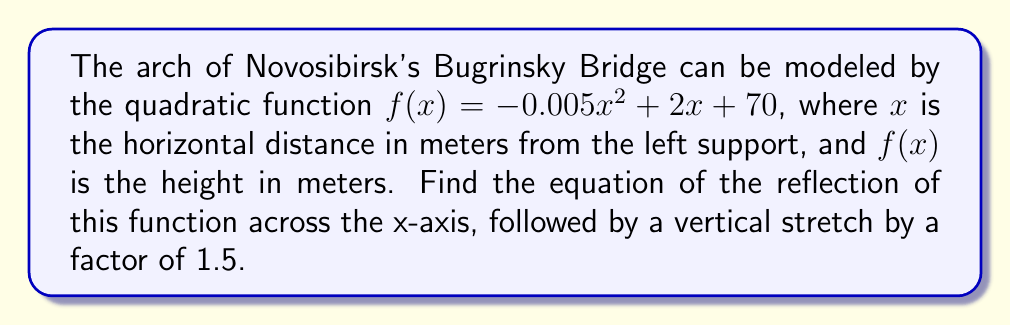Can you solve this math problem? To solve this problem, we'll follow these steps:

1) First, let's reflect the function across the x-axis. This is done by negating the entire function:

   $g(x) = -f(x) = -(-0.005x^2 + 2x + 70)$
   $g(x) = 0.005x^2 - 2x - 70$

2) Now, we need to apply a vertical stretch by a factor of 1.5. This is done by multiplying the entire function by 1.5:

   $h(x) = 1.5g(x) = 1.5(0.005x^2 - 2x - 70)$

3) Let's distribute the 1.5:

   $h(x) = 1.5(0.005x^2) - 1.5(2x) - 1.5(70)$
   $h(x) = 0.0075x^2 - 3x - 105$

Therefore, the final equation after reflection and stretch is $h(x) = 0.0075x^2 - 3x - 105$.
Answer: $h(x) = 0.0075x^2 - 3x - 105$ 